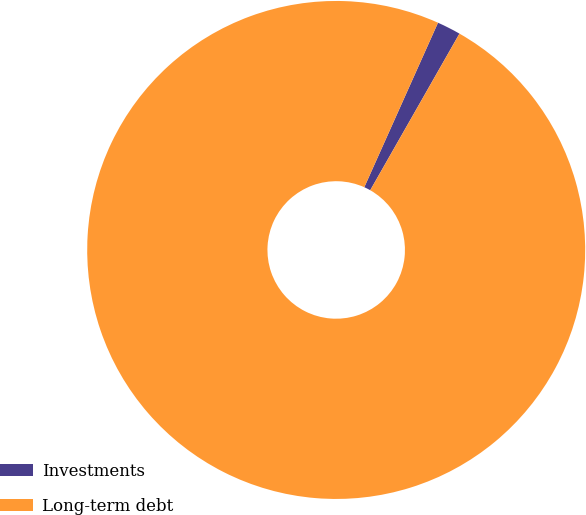Convert chart. <chart><loc_0><loc_0><loc_500><loc_500><pie_chart><fcel>Investments<fcel>Long-term debt<nl><fcel>1.54%<fcel>98.46%<nl></chart> 